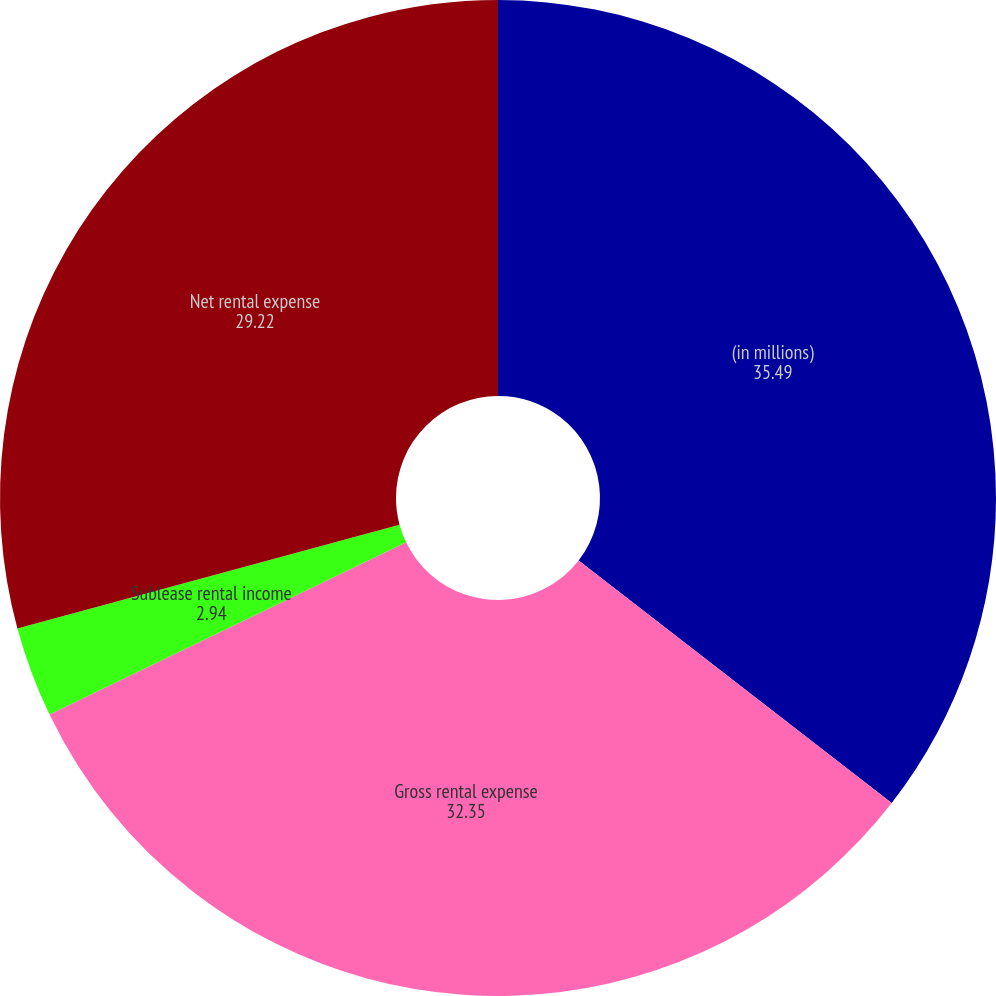Convert chart. <chart><loc_0><loc_0><loc_500><loc_500><pie_chart><fcel>(in millions)<fcel>Gross rental expense<fcel>Sublease rental income<fcel>Net rental expense<nl><fcel>35.49%<fcel>32.35%<fcel>2.94%<fcel>29.22%<nl></chart> 